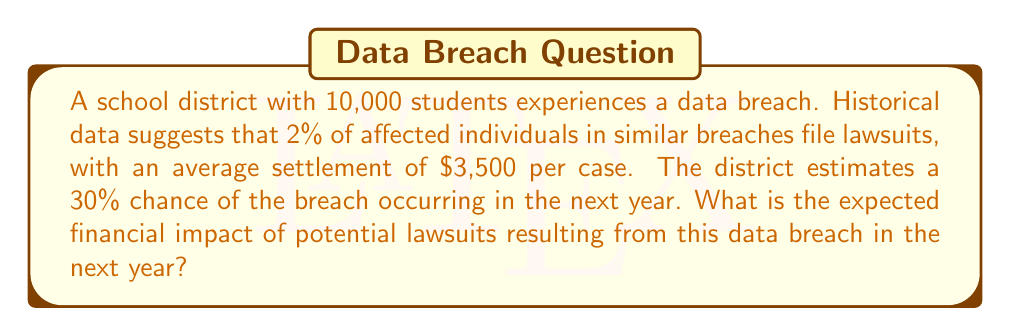What is the answer to this math problem? To calculate the expected financial impact, we'll follow these steps:

1. Calculate the number of expected lawsuits:
   Number of students: 10,000
   Percentage filing lawsuits: 2% = 0.02
   Expected lawsuits = $10,000 \times 0.02 = 200$ lawsuits

2. Calculate the total cost of settlements:
   Average settlement: $3,500
   Total settlement cost = $200 \times \$3,500 = \$700,000$

3. Calculate the expected value considering the probability of the breach:
   Probability of breach occurring: 30% = 0.3
   Expected financial impact = $\$700,000 \times 0.3 = \$210,000$

The expected financial impact is calculated using the formula:

$$ E(\text{Impact}) = \text{Number of students} \times \text{Lawsuit rate} \times \text{Average settlement} \times \text{Probability of breach} $$

$$ E(\text{Impact}) = 10,000 \times 0.02 \times \$3,500 \times 0.3 = \$210,000 $$

This value represents the statistical expectation of the financial impact from potential lawsuits resulting from a data breach in the next year.
Answer: $210,000 